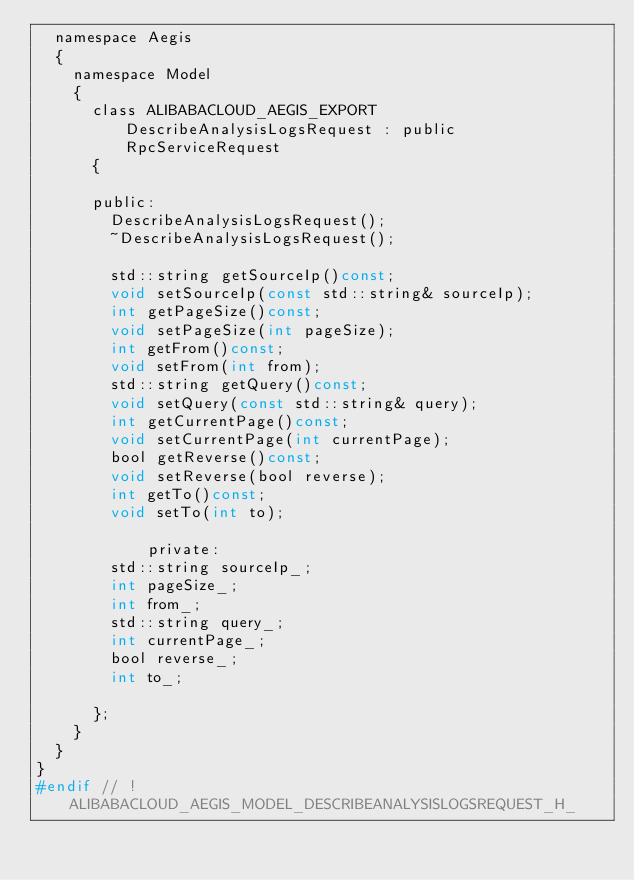<code> <loc_0><loc_0><loc_500><loc_500><_C_>	namespace Aegis
	{
		namespace Model
		{
			class ALIBABACLOUD_AEGIS_EXPORT DescribeAnalysisLogsRequest : public RpcServiceRequest
			{

			public:
				DescribeAnalysisLogsRequest();
				~DescribeAnalysisLogsRequest();

				std::string getSourceIp()const;
				void setSourceIp(const std::string& sourceIp);
				int getPageSize()const;
				void setPageSize(int pageSize);
				int getFrom()const;
				void setFrom(int from);
				std::string getQuery()const;
				void setQuery(const std::string& query);
				int getCurrentPage()const;
				void setCurrentPage(int currentPage);
				bool getReverse()const;
				void setReverse(bool reverse);
				int getTo()const;
				void setTo(int to);

            private:
				std::string sourceIp_;
				int pageSize_;
				int from_;
				std::string query_;
				int currentPage_;
				bool reverse_;
				int to_;

			};
		}
	}
}
#endif // !ALIBABACLOUD_AEGIS_MODEL_DESCRIBEANALYSISLOGSREQUEST_H_</code> 